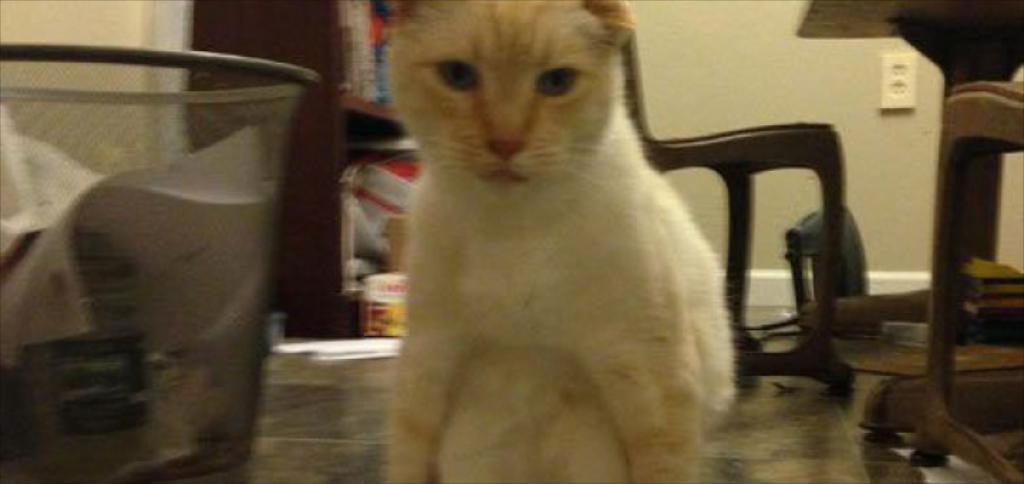Describe this image in one or two sentences. In this picture we can see a cat,table,chair,wall and some objects. 